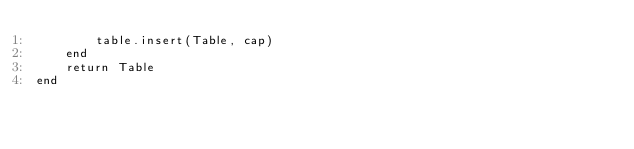<code> <loc_0><loc_0><loc_500><loc_500><_Lua_>        table.insert(Table, cap)
    end
    return Table
end
</code> 